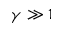<formula> <loc_0><loc_0><loc_500><loc_500>\gamma \gg 1</formula> 